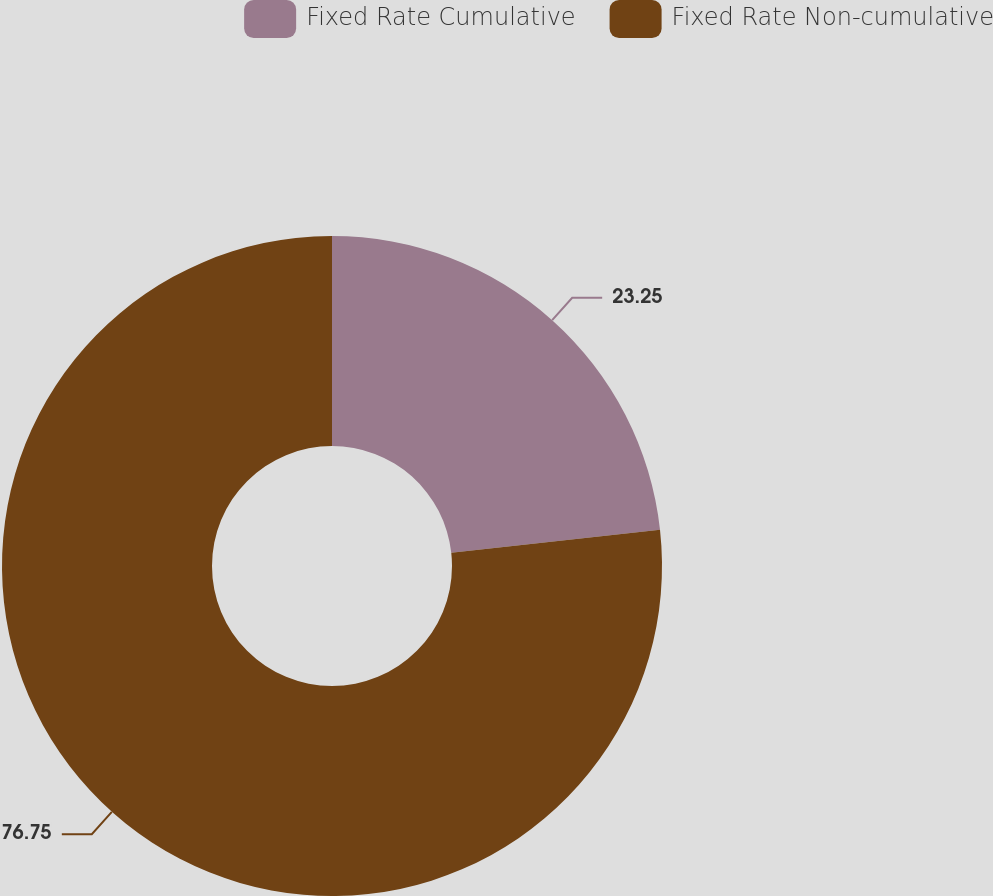<chart> <loc_0><loc_0><loc_500><loc_500><pie_chart><fcel>Fixed Rate Cumulative<fcel>Fixed Rate Non-cumulative<nl><fcel>23.25%<fcel>76.75%<nl></chart> 